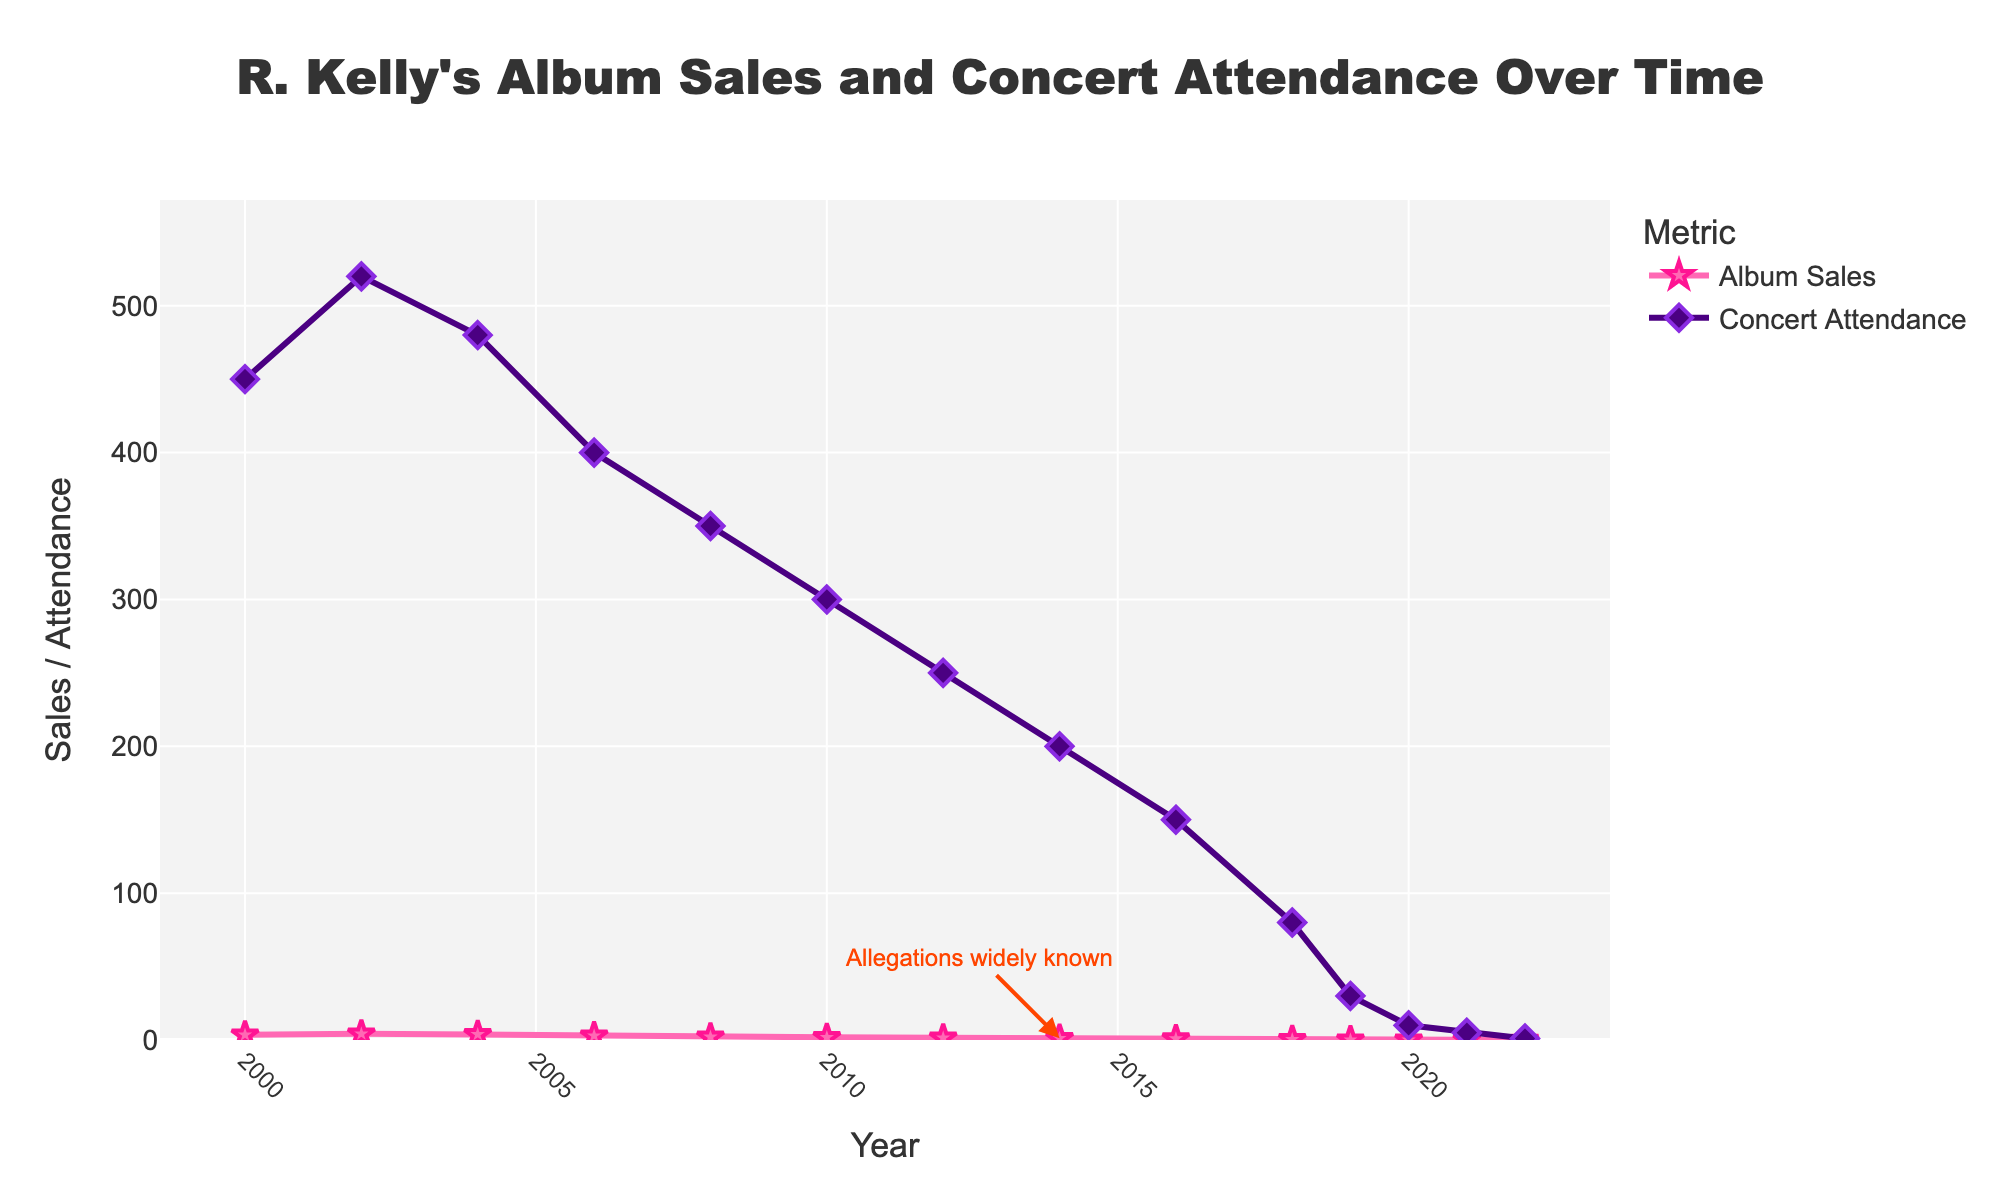Which year had the highest album sales? The figure shows the peaks and valleys of the album sales line. The highest point is in 2002.
Answer: 2002 How do album sales in 2018 compare to those in 2006? Look at the y-values for album sales in both years. 2018 is at 0.4 million and 2006 is at 2.9 million. Subtract 0.4 from 2.9 to find the difference.
Answer: Sales in 2018 are 2.5 million less than in 2006 In which year did concert attendance see the most significant drop compared to the previous year? Examine the slope of the concert attendance line. The steepest decline is between 2018 and 2019, dropping from 80,000 to 30,000.
Answer: 2019 What is the sum of the album sales for the years 2012, 2014, and 2016? Add the album sales figures for each year: 1.5 + 1.2 + 0.9.
Answer: 3.6 million At what point did both album sales and concert attendance begin to significantly decline? Look for the trend before and after the label of "Allegations widely known" in 2014. Both metrics sharply decline post-2014.
Answer: 2014 What was the difference in concert attendance between 2002 and 2022? Subtract concert attendance in 2022 from that in 2002: 520,000 - 1,000.
Answer: 519,000 Compare the rate of decline in album sales between 2006-2008 and 2014-2016. Which period had a sharper decline? Compare the slopes of the album sales line between the two periods. From 2006 to 2008, it declines from 2.9 to 2.1 (0.8), while from 2014 to 2016, it drops from 1.2 to 0.9 (0.3). The slope from 2006 to 2008 is steeper.
Answer: 2006-2008 How does the visual appearance of the data points' markers for album sales differ from those for concert attendance? The album sales markers are stars with pink color, while concert attendance markers are diamonds with purple color.
Answer: Stars vs Diamonds, Pink vs Purple What was the percentage decrease in album sales from 2002 to 2022? Calculate the percentage decrease: (4.2 million - 0.02 million) / 4.2 million * 100%.
Answer: 99.52% 